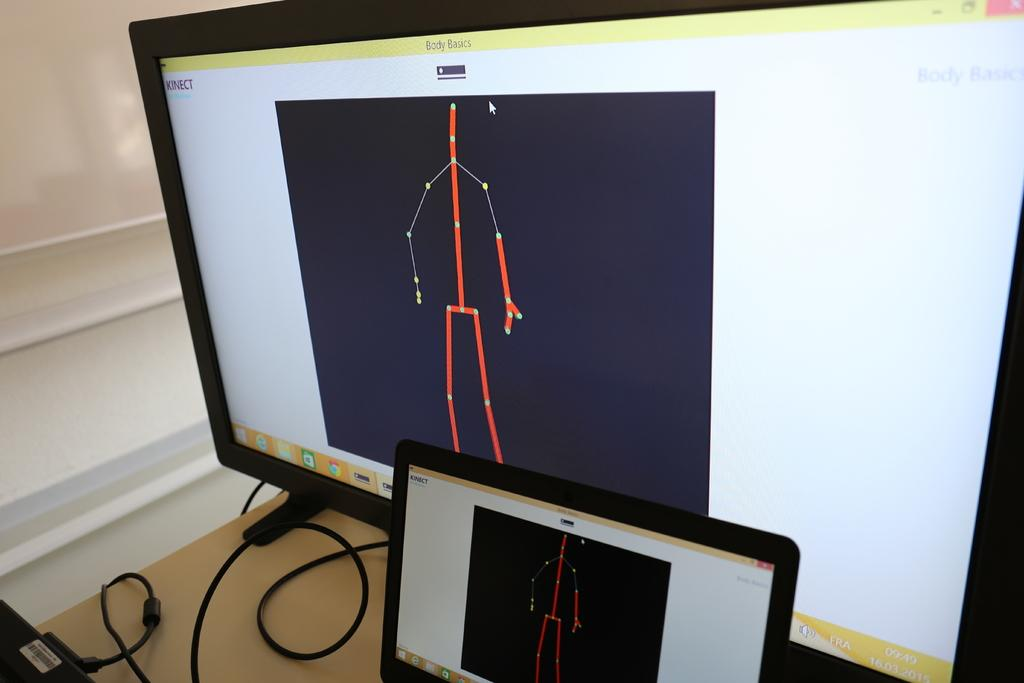<image>
Give a short and clear explanation of the subsequent image. A computer monitor is displaying a stick outline of a body with the word body basics above it. 